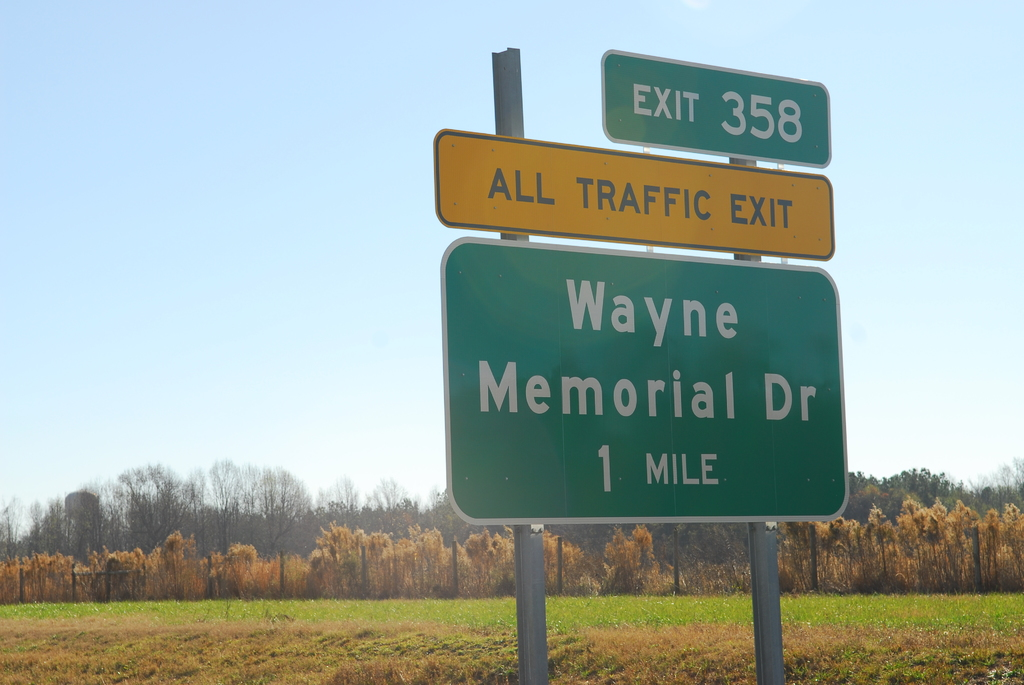What might one find along Wayne Memorial Drive that is significant enough to redirect all traffic? Wayne Memorial Drive could host critical facilities or locations that require such redirection. This might include hospitals, emergency service centers, or a popular venue hosting a large event. Additionally, the nature of the surroundings—visible as a blend of open fields and clusters of trees—suggests rural or semi-urban settings that might not have many alternate routes, making this road especially crucial for local traffic management. 